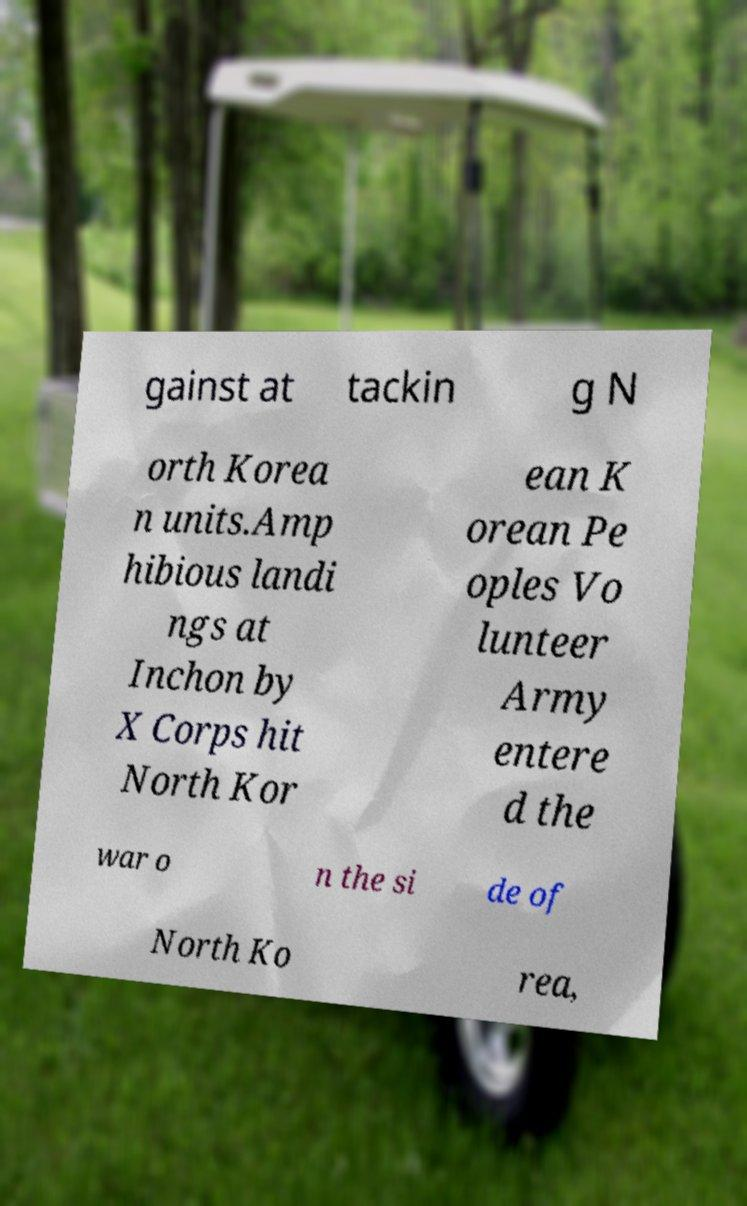I need the written content from this picture converted into text. Can you do that? gainst at tackin g N orth Korea n units.Amp hibious landi ngs at Inchon by X Corps hit North Kor ean K orean Pe oples Vo lunteer Army entere d the war o n the si de of North Ko rea, 